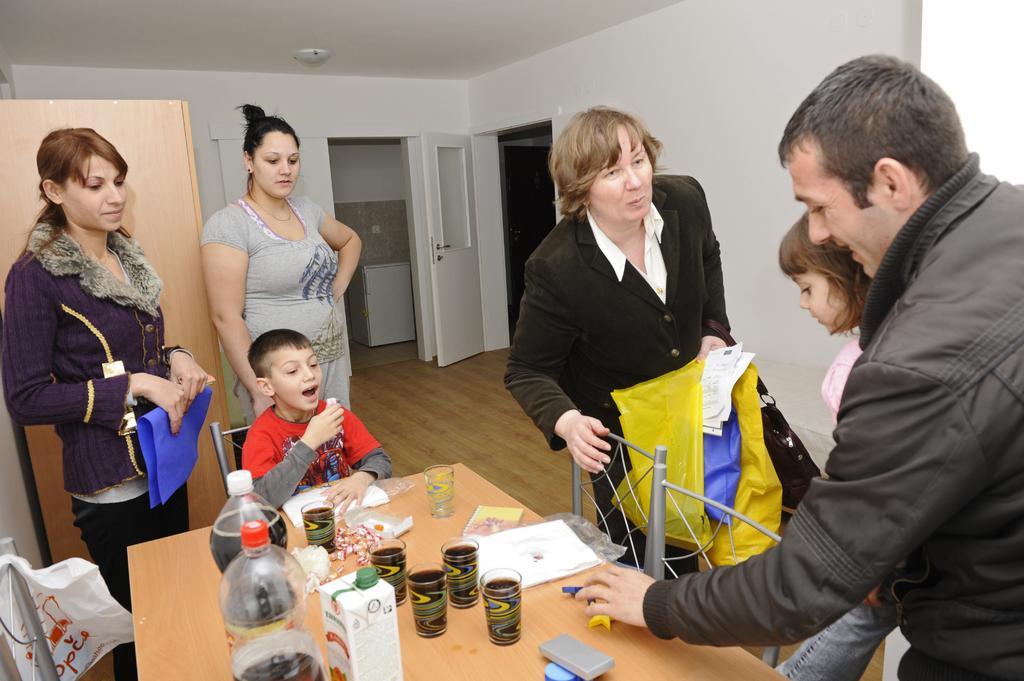Could you give a brief overview of what you see in this image? In this picture we can see group of people, few are standing and a boy is seated on the chair, in front of them we can see few glasses, bottles and other things on the table, in the background we can see a door. 